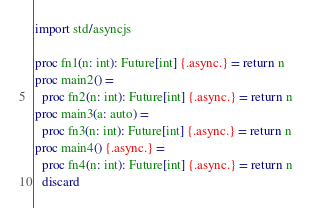<code> <loc_0><loc_0><loc_500><loc_500><_Nim_>import std/asyncjs

proc fn1(n: int): Future[int] {.async.} = return n
proc main2() =
  proc fn2(n: int): Future[int] {.async.} = return n
proc main3(a: auto) =
  proc fn3(n: int): Future[int] {.async.} = return n
proc main4() {.async.} =
  proc fn4(n: int): Future[int] {.async.} = return n
  discard
</code> 